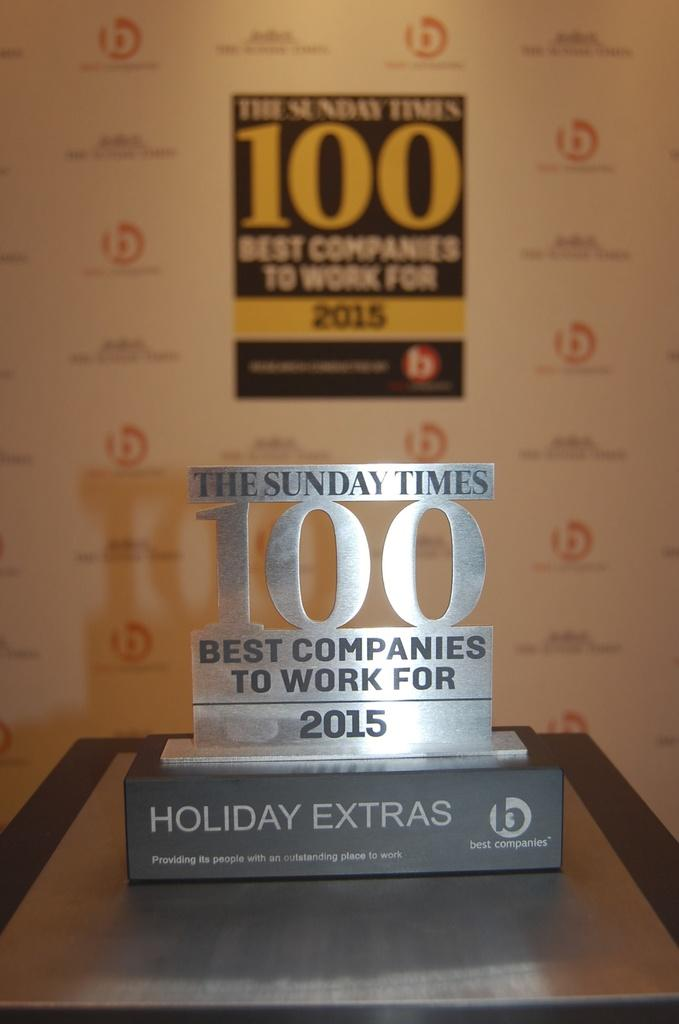<image>
Relay a brief, clear account of the picture shown. An award from The Sunday Times for best companies to work for in 2015. 